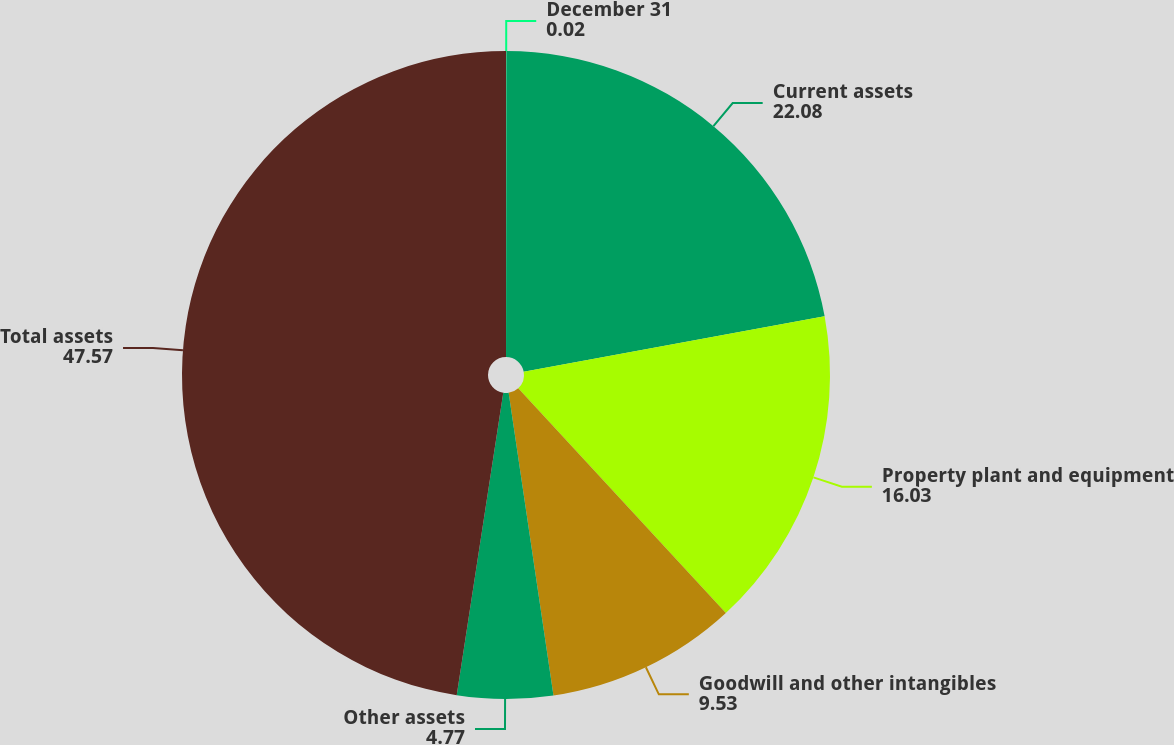Convert chart to OTSL. <chart><loc_0><loc_0><loc_500><loc_500><pie_chart><fcel>December 31<fcel>Current assets<fcel>Property plant and equipment<fcel>Goodwill and other intangibles<fcel>Other assets<fcel>Total assets<nl><fcel>0.02%<fcel>22.08%<fcel>16.03%<fcel>9.53%<fcel>4.77%<fcel>47.57%<nl></chart> 